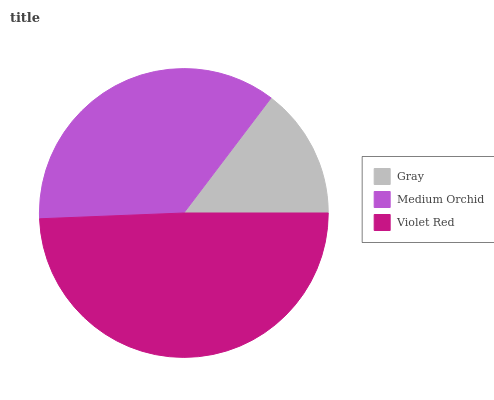Is Gray the minimum?
Answer yes or no. Yes. Is Violet Red the maximum?
Answer yes or no. Yes. Is Medium Orchid the minimum?
Answer yes or no. No. Is Medium Orchid the maximum?
Answer yes or no. No. Is Medium Orchid greater than Gray?
Answer yes or no. Yes. Is Gray less than Medium Orchid?
Answer yes or no. Yes. Is Gray greater than Medium Orchid?
Answer yes or no. No. Is Medium Orchid less than Gray?
Answer yes or no. No. Is Medium Orchid the high median?
Answer yes or no. Yes. Is Medium Orchid the low median?
Answer yes or no. Yes. Is Violet Red the high median?
Answer yes or no. No. Is Gray the low median?
Answer yes or no. No. 